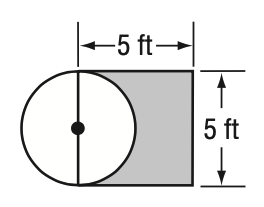Question: One side of a square is a diameter of a circle. The length of one side of the square is 5 feet. To the nearest hundredth, what is the probability that a point chosen at random is in the shaded region?
Choices:
A. 0.08
B. 0.22
C. 0.44
D. 0.77
Answer with the letter. Answer: C 